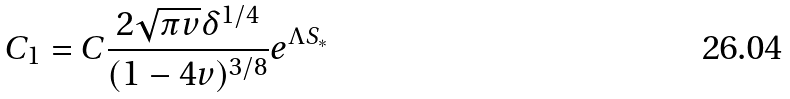Convert formula to latex. <formula><loc_0><loc_0><loc_500><loc_500>C _ { 1 } = C \frac { 2 \sqrt { \pi v } \delta ^ { 1 / 4 } } { ( 1 - 4 v ) ^ { 3 / 8 } } e ^ { \Lambda S _ { * } }</formula> 